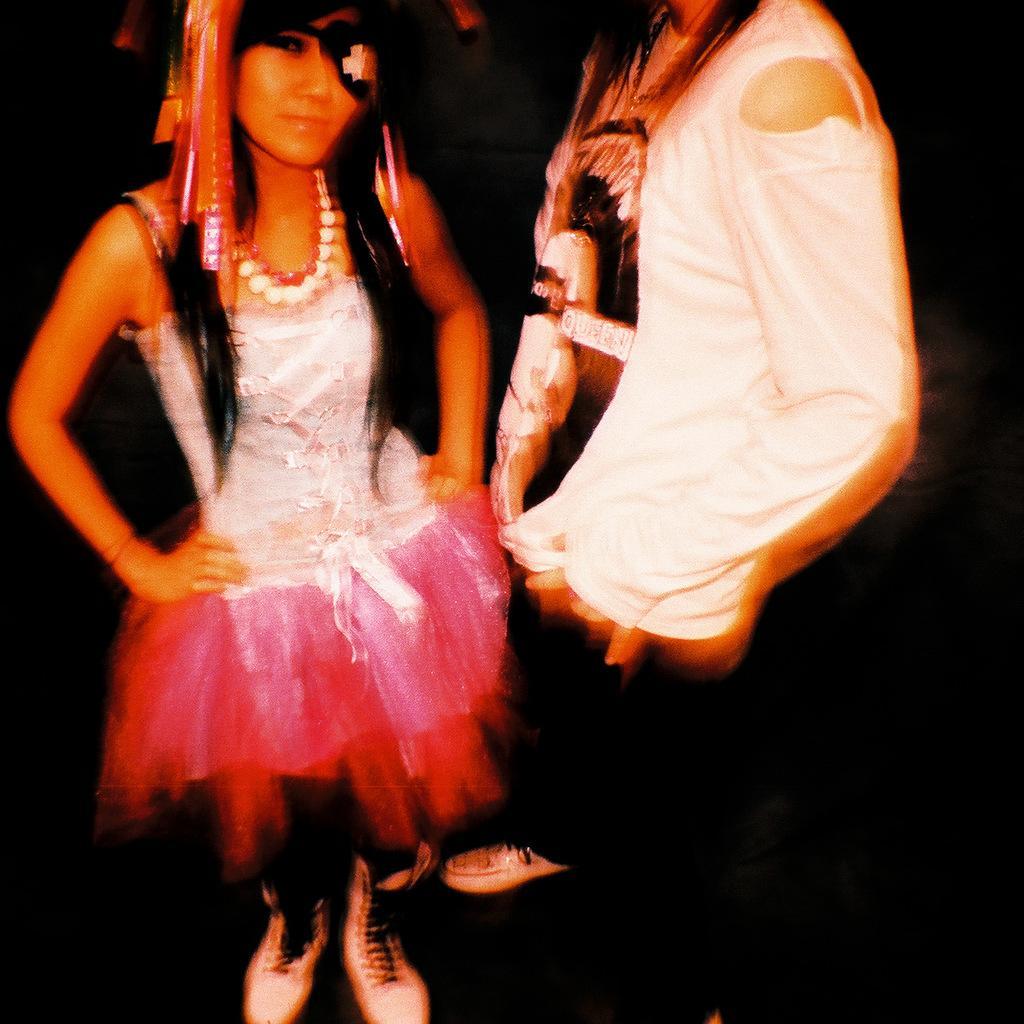How would you summarize this image in a sentence or two? In this picture there is a woman with white and pink dress is standing and there is a person with white t-shirt is standing. At the back there is a black background. 